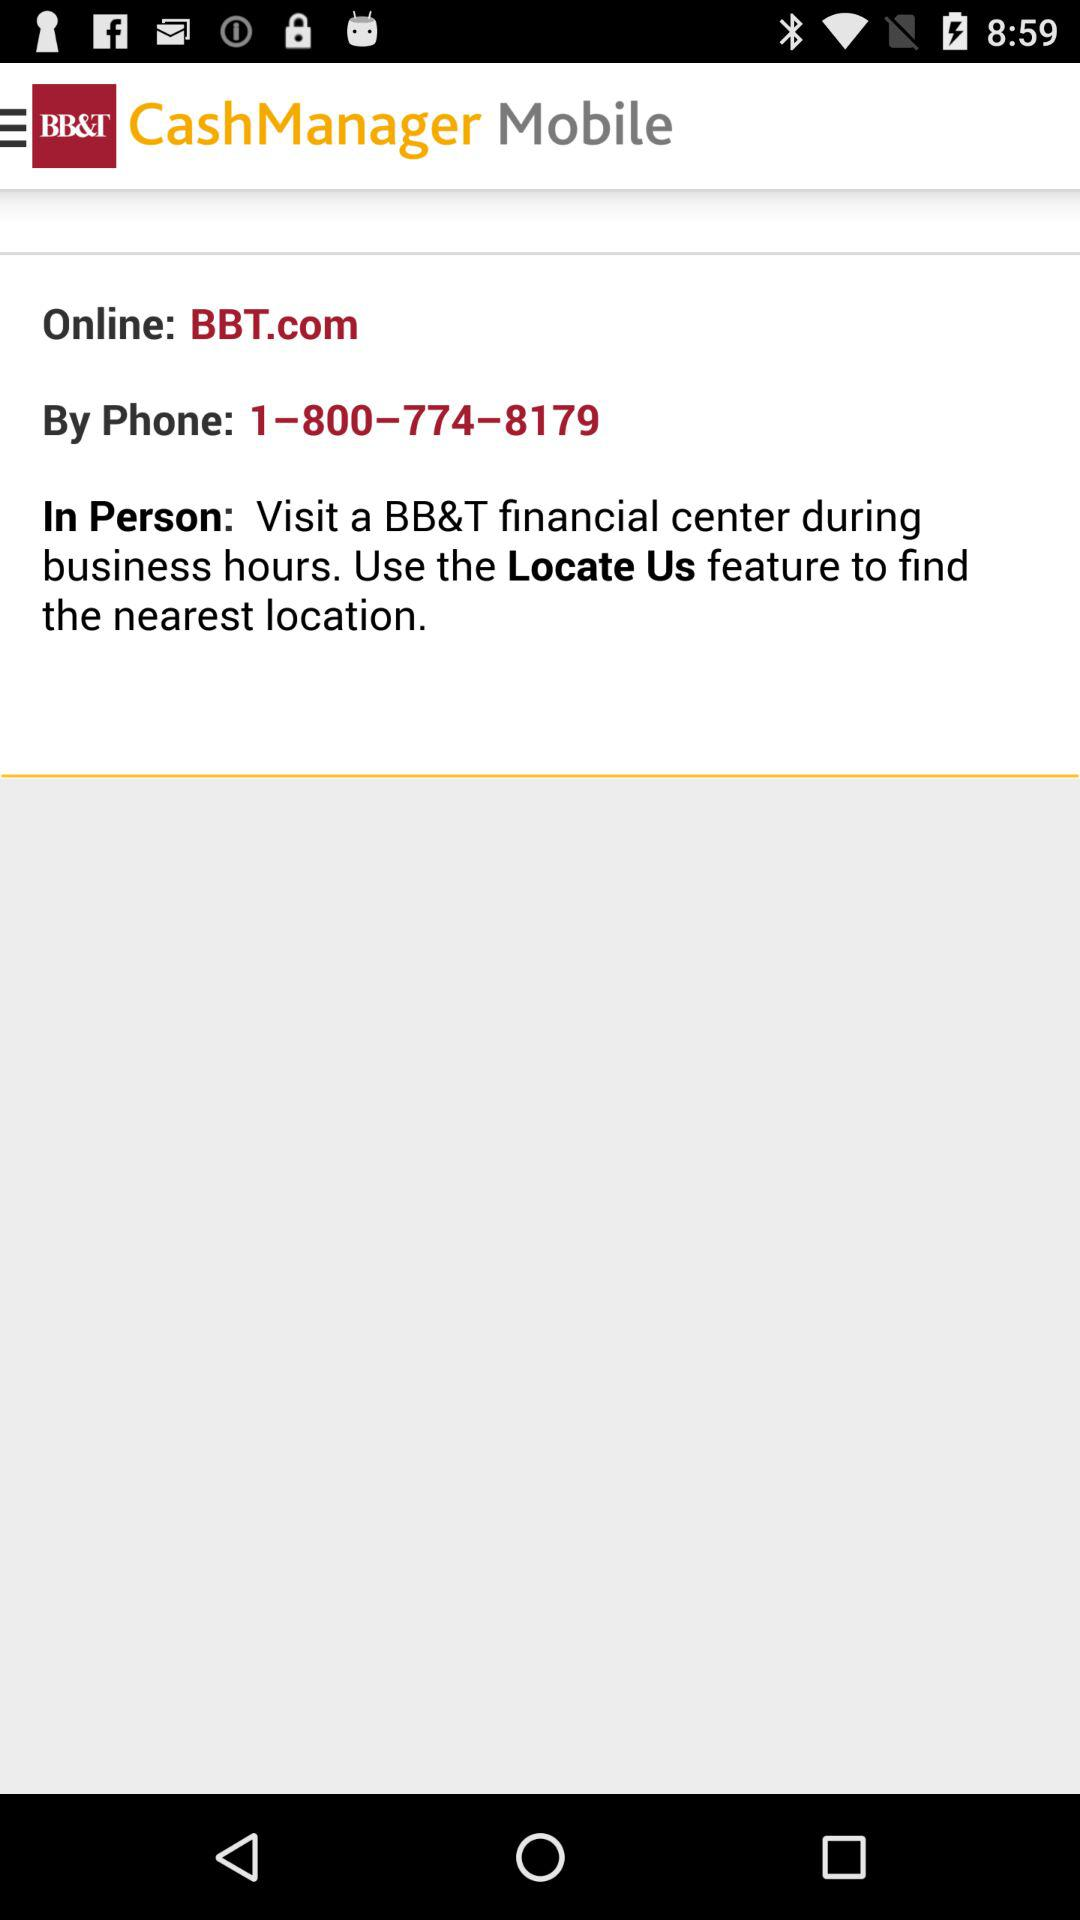What is the phone number? The phone number is 1–800–774–8179. 